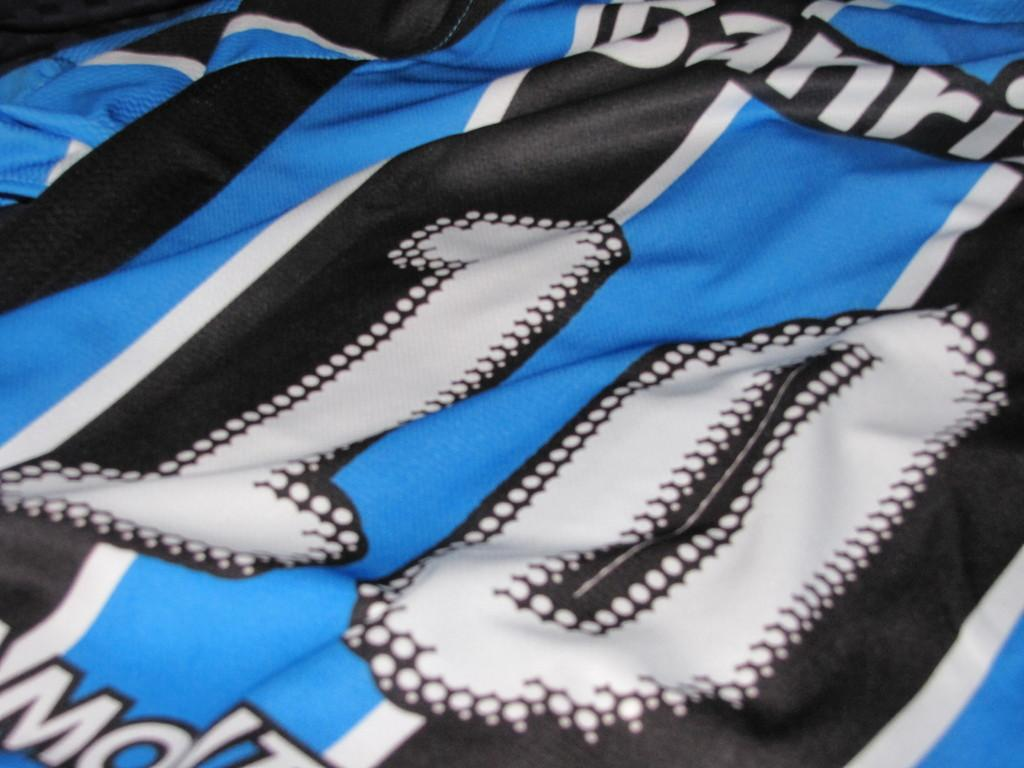<image>
Present a compact description of the photo's key features. A striped shirt has the number 10 on it. 